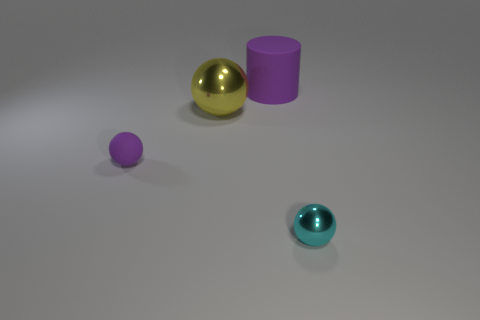Could you infer the texture of the objects from the image? From the image, the objects seem to have a smooth texture. The reflections on the yellow and teal spheres suggest a shiny, perhaps metallic or polished surface, while the purple cylinder and sphere appear matte, indicating a non-reflective, possibly plastic material. 